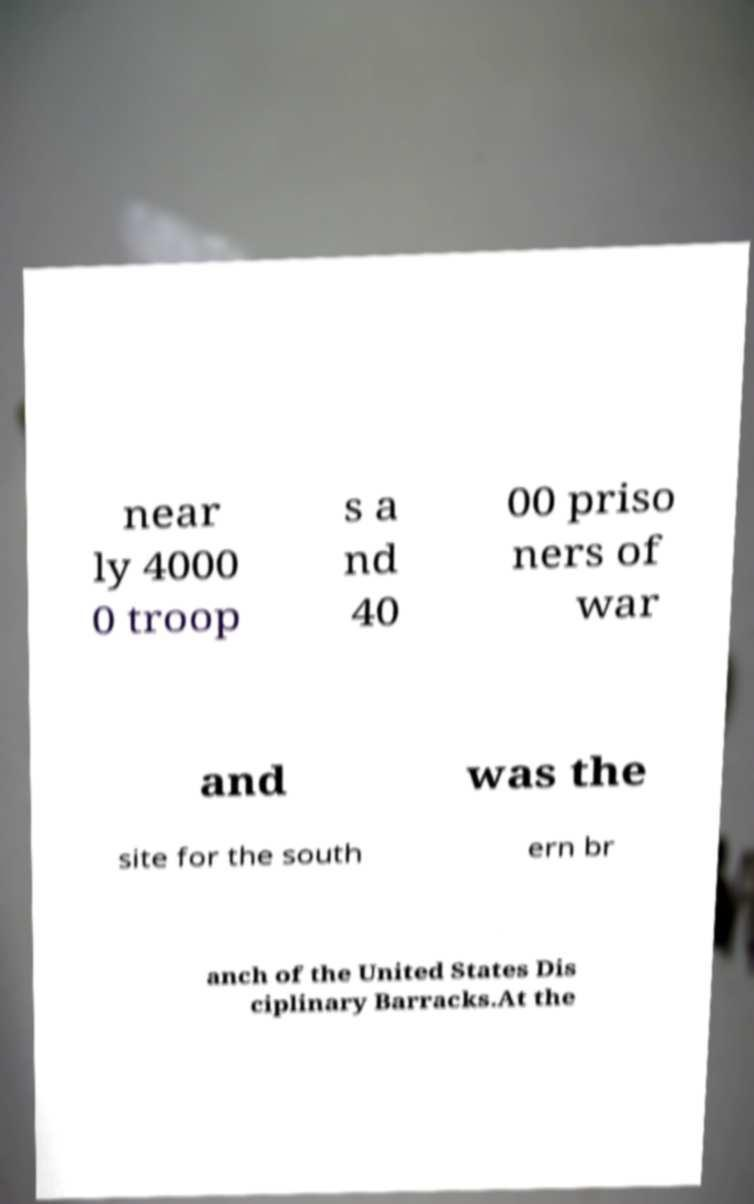Please read and relay the text visible in this image. What does it say? near ly 4000 0 troop s a nd 40 00 priso ners of war and was the site for the south ern br anch of the United States Dis ciplinary Barracks.At the 